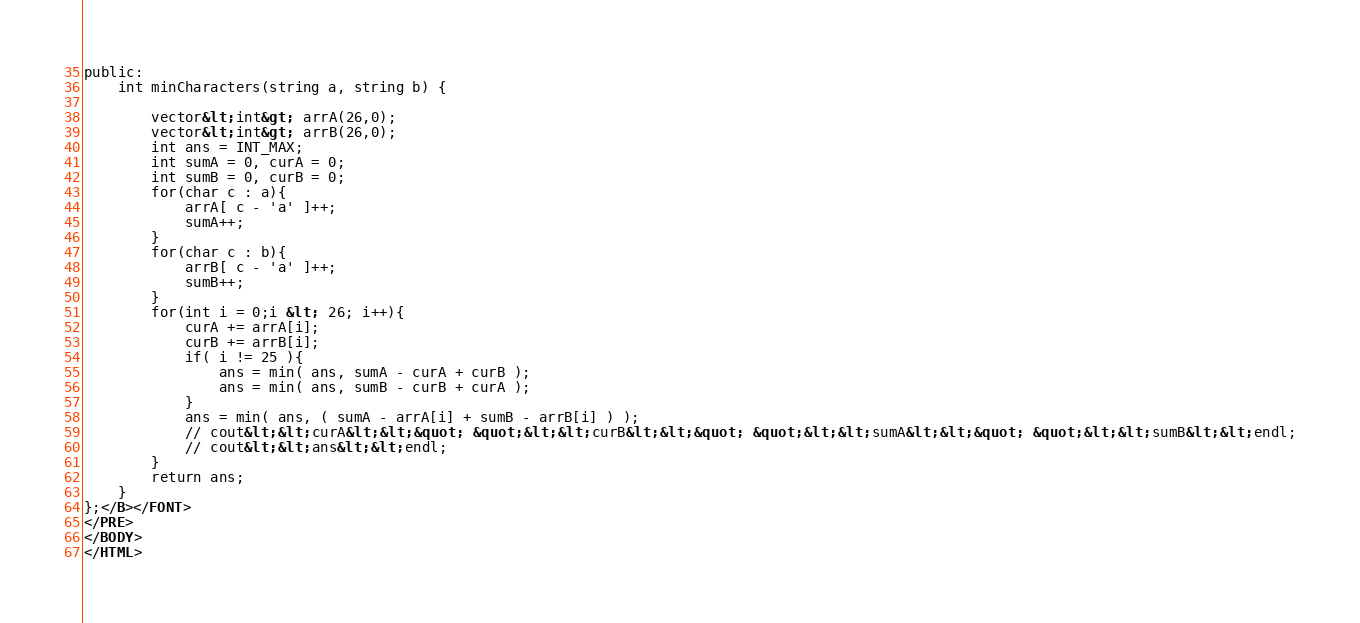<code> <loc_0><loc_0><loc_500><loc_500><_HTML_>public:
    int minCharacters(string a, string b) {
        
        vector&lt;int&gt; arrA(26,0);
        vector&lt;int&gt; arrB(26,0);
        int ans = INT_MAX;
        int sumA = 0, curA = 0;
        int sumB = 0, curB = 0;
        for(char c : a){
            arrA[ c - 'a' ]++;
            sumA++;
        }
        for(char c : b){
            arrB[ c - 'a' ]++;
            sumB++;
        }
        for(int i = 0;i &lt; 26; i++){
            curA += arrA[i];
            curB += arrB[i];
            if( i != 25 ){
                ans = min( ans, sumA - curA + curB );
                ans = min( ans, sumB - curB + curA );
            }
            ans = min( ans, ( sumA - arrA[i] + sumB - arrB[i] ) );
            // cout&lt;&lt;curA&lt;&lt;&quot; &quot;&lt;&lt;curB&lt;&lt;&quot; &quot;&lt;&lt;sumA&lt;&lt;&quot; &quot;&lt;&lt;sumB&lt;&lt;endl;
            // cout&lt;&lt;ans&lt;&lt;endl;
        }
        return ans;
    }
};</B></FONT>
</PRE>
</BODY>
</HTML>
</code> 